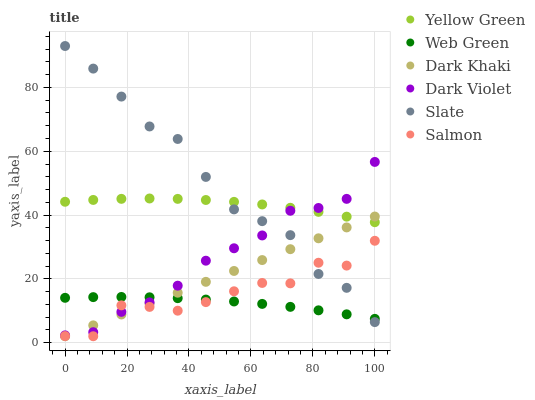Does Web Green have the minimum area under the curve?
Answer yes or no. Yes. Does Slate have the maximum area under the curve?
Answer yes or no. Yes. Does Salmon have the minimum area under the curve?
Answer yes or no. No. Does Salmon have the maximum area under the curve?
Answer yes or no. No. Is Dark Khaki the smoothest?
Answer yes or no. Yes. Is Salmon the roughest?
Answer yes or no. Yes. Is Slate the smoothest?
Answer yes or no. No. Is Slate the roughest?
Answer yes or no. No. Does Salmon have the lowest value?
Answer yes or no. Yes. Does Slate have the lowest value?
Answer yes or no. No. Does Slate have the highest value?
Answer yes or no. Yes. Does Salmon have the highest value?
Answer yes or no. No. Is Salmon less than Yellow Green?
Answer yes or no. Yes. Is Yellow Green greater than Salmon?
Answer yes or no. Yes. Does Dark Violet intersect Slate?
Answer yes or no. Yes. Is Dark Violet less than Slate?
Answer yes or no. No. Is Dark Violet greater than Slate?
Answer yes or no. No. Does Salmon intersect Yellow Green?
Answer yes or no. No. 